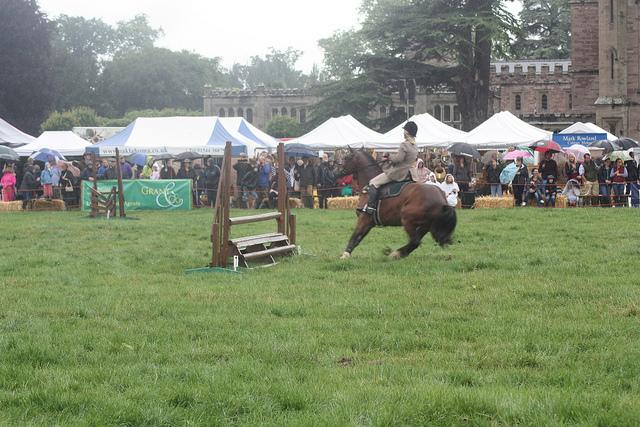How many horses are there?
Quick response, please. 1. What is the person riding?
Answer briefly. Horse. Are there lots of spectators?
Give a very brief answer. Yes. What kind of show is this?
Be succinct. Horse. 